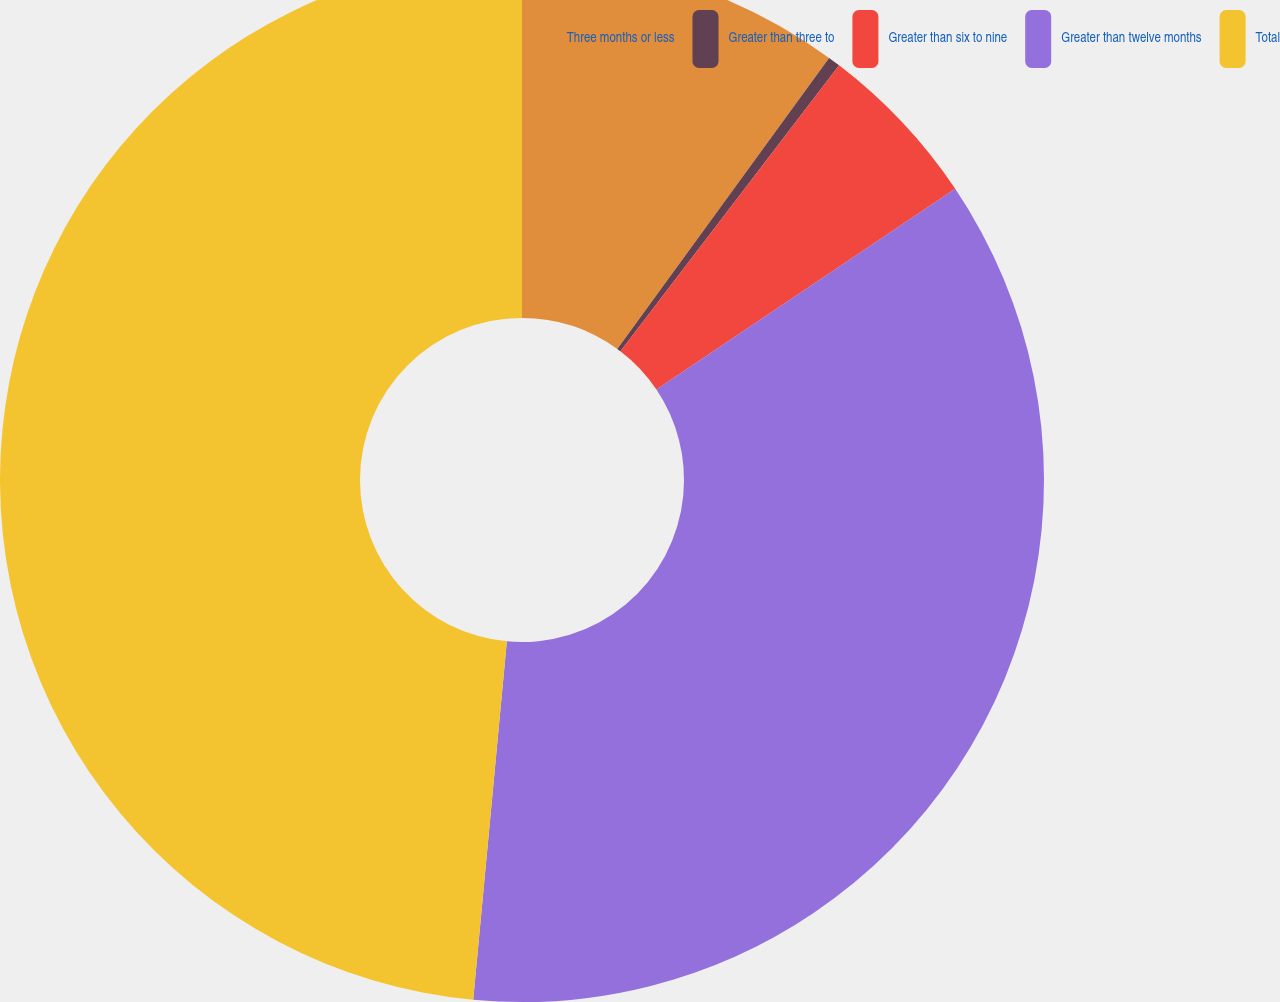Convert chart. <chart><loc_0><loc_0><loc_500><loc_500><pie_chart><fcel>Three months or less<fcel>Greater than three to<fcel>Greater than six to nine<fcel>Greater than twelve months<fcel>Total<nl><fcel>10.01%<fcel>0.38%<fcel>5.19%<fcel>35.91%<fcel>48.51%<nl></chart> 